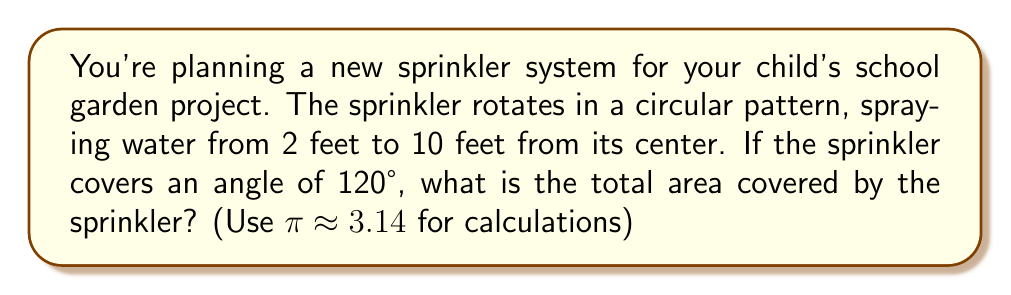Could you help me with this problem? Let's approach this step-by-step using polar coordinates:

1) The area covered by the sprinkler forms a sector of a circle. In polar coordinates, we can calculate this area using the formula:

   $$A = \frac{1}{2} \int_{\theta_1}^{\theta_2} (r(\theta))^2 d\theta$$

   where $r(\theta)$ is the radius as a function of $\theta$.

2) In this case, $r(\theta)$ varies from 2 feet to 10 feet, regardless of $\theta$. We need to subtract the area of the smaller sector from the larger one:

   $$A = \frac{1}{2} \int_0^{120°} (10^2 - 2^2) d\theta$$

3) The angle is given in degrees, but we need to convert it to radians:
   
   $$120° = \frac{120 \pi}{180} = \frac{2\pi}{3} \text{ radians}$$

4) Now we can calculate:

   $$A = \frac{1}{2} (10^2 - 2^2) \int_0^{2\pi/3} d\theta$$
   $$A = \frac{1}{2} (100 - 4) \cdot \frac{2\pi}{3}$$
   $$A = 48 \cdot \frac{\pi}{3}$$

5) Using $\pi \approx 3.14$:

   $$A \approx 48 \cdot \frac{3.14}{3} \approx 50.24 \text{ square feet}$$

[asy]
import geometry;

size(200);
fill(scale(50)*sector(10,0,2pi/3), gray(0.9));
fill(scale(50)*sector(2,0,2pi/3), white);
draw(scale(50)*arc((0,0),10,0,120), black+1);
draw(scale(50)*arc((0,0),2,0,120), black+1);
draw(scale(50)*((10,0)--(0,0)--(10*cos(2pi/3),10*sin(2pi/3))), black+1);
label("10 ft", (250,125), E);
label("2 ft", (50,25), E);
label("120°", (125,216), N);
[/asy]
Answer: The total area covered by the sprinkler is approximately 50.24 square feet. 